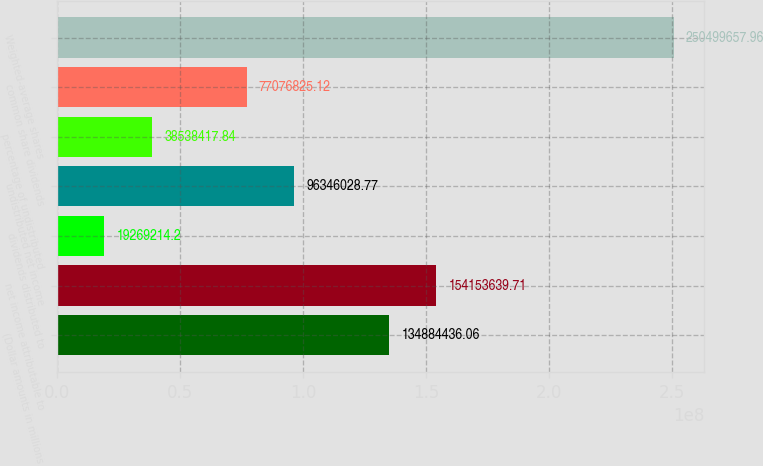<chart> <loc_0><loc_0><loc_500><loc_500><bar_chart><fcel>(Dollar amounts in millions<fcel>net income attributable to<fcel>dividends distributed to<fcel>undistributed net income<fcel>percentage of undistributed<fcel>common share dividends<fcel>Weighted-average shares<nl><fcel>1.34884e+08<fcel>1.54154e+08<fcel>1.92692e+07<fcel>9.6346e+07<fcel>3.85384e+07<fcel>7.70768e+07<fcel>2.505e+08<nl></chart> 